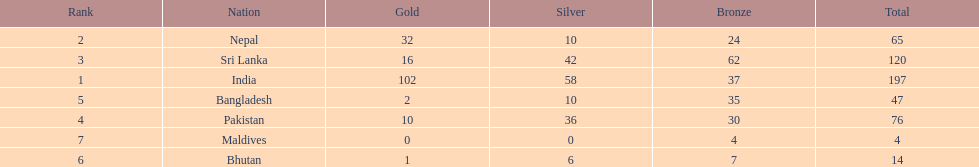What is the difference in total number of medals between india and nepal? 132. 